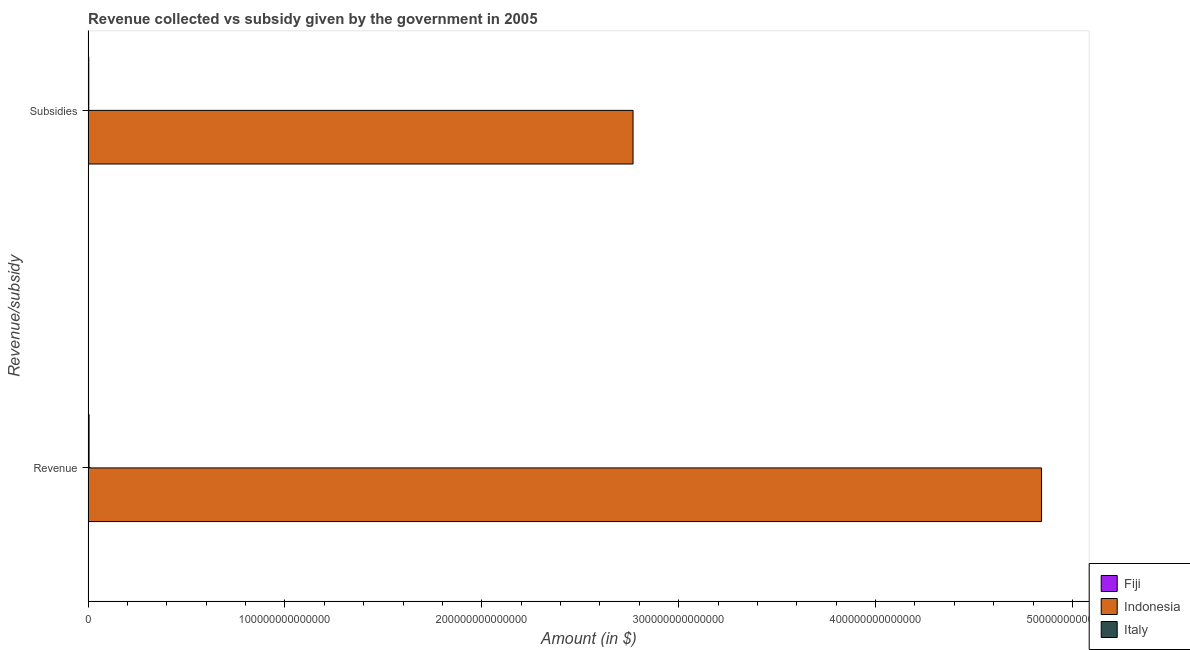How many bars are there on the 1st tick from the top?
Offer a very short reply. 3. How many bars are there on the 2nd tick from the bottom?
Ensure brevity in your answer.  3. What is the label of the 1st group of bars from the top?
Provide a short and direct response. Subsidies. What is the amount of subsidies given in Indonesia?
Give a very brief answer. 2.77e+14. Across all countries, what is the maximum amount of revenue collected?
Your answer should be very brief. 4.84e+14. Across all countries, what is the minimum amount of subsidies given?
Your answer should be very brief. 2.88e+08. In which country was the amount of revenue collected minimum?
Offer a terse response. Fiji. What is the total amount of subsidies given in the graph?
Keep it short and to the point. 2.77e+14. What is the difference between the amount of subsidies given in Fiji and that in Indonesia?
Give a very brief answer. -2.77e+14. What is the difference between the amount of revenue collected in Fiji and the amount of subsidies given in Italy?
Ensure brevity in your answer.  -3.48e+11. What is the average amount of revenue collected per country?
Provide a short and direct response. 1.62e+14. What is the difference between the amount of revenue collected and amount of subsidies given in Indonesia?
Offer a terse response. 2.07e+14. What is the ratio of the amount of subsidies given in Indonesia to that in Fiji?
Your answer should be compact. 9.62e+05. How many countries are there in the graph?
Your answer should be compact. 3. What is the difference between two consecutive major ticks on the X-axis?
Your answer should be very brief. 1.00e+14. Where does the legend appear in the graph?
Provide a short and direct response. Bottom right. How many legend labels are there?
Offer a very short reply. 3. What is the title of the graph?
Offer a very short reply. Revenue collected vs subsidy given by the government in 2005. Does "East Asia (all income levels)" appear as one of the legend labels in the graph?
Make the answer very short. No. What is the label or title of the X-axis?
Keep it short and to the point. Amount (in $). What is the label or title of the Y-axis?
Provide a short and direct response. Revenue/subsidy. What is the Amount (in $) in Fiji in Revenue?
Ensure brevity in your answer.  1.22e+09. What is the Amount (in $) of Indonesia in Revenue?
Keep it short and to the point. 4.84e+14. What is the Amount (in $) in Italy in Revenue?
Your answer should be compact. 5.03e+11. What is the Amount (in $) of Fiji in Subsidies?
Offer a very short reply. 2.88e+08. What is the Amount (in $) in Indonesia in Subsidies?
Your response must be concise. 2.77e+14. What is the Amount (in $) of Italy in Subsidies?
Your answer should be very brief. 3.49e+11. Across all Revenue/subsidy, what is the maximum Amount (in $) of Fiji?
Your answer should be very brief. 1.22e+09. Across all Revenue/subsidy, what is the maximum Amount (in $) in Indonesia?
Ensure brevity in your answer.  4.84e+14. Across all Revenue/subsidy, what is the maximum Amount (in $) of Italy?
Offer a very short reply. 5.03e+11. Across all Revenue/subsidy, what is the minimum Amount (in $) in Fiji?
Provide a succinct answer. 2.88e+08. Across all Revenue/subsidy, what is the minimum Amount (in $) in Indonesia?
Offer a terse response. 2.77e+14. Across all Revenue/subsidy, what is the minimum Amount (in $) in Italy?
Ensure brevity in your answer.  3.49e+11. What is the total Amount (in $) of Fiji in the graph?
Provide a succinct answer. 1.50e+09. What is the total Amount (in $) in Indonesia in the graph?
Provide a short and direct response. 7.61e+14. What is the total Amount (in $) of Italy in the graph?
Ensure brevity in your answer.  8.53e+11. What is the difference between the Amount (in $) of Fiji in Revenue and that in Subsidies?
Keep it short and to the point. 9.28e+08. What is the difference between the Amount (in $) of Indonesia in Revenue and that in Subsidies?
Give a very brief answer. 2.07e+14. What is the difference between the Amount (in $) in Italy in Revenue and that in Subsidies?
Ensure brevity in your answer.  1.54e+11. What is the difference between the Amount (in $) of Fiji in Revenue and the Amount (in $) of Indonesia in Subsidies?
Your response must be concise. -2.77e+14. What is the difference between the Amount (in $) in Fiji in Revenue and the Amount (in $) in Italy in Subsidies?
Your answer should be very brief. -3.48e+11. What is the difference between the Amount (in $) in Indonesia in Revenue and the Amount (in $) in Italy in Subsidies?
Make the answer very short. 4.84e+14. What is the average Amount (in $) of Fiji per Revenue/subsidy?
Give a very brief answer. 7.52e+08. What is the average Amount (in $) in Indonesia per Revenue/subsidy?
Your answer should be compact. 3.81e+14. What is the average Amount (in $) in Italy per Revenue/subsidy?
Offer a very short reply. 4.26e+11. What is the difference between the Amount (in $) of Fiji and Amount (in $) of Indonesia in Revenue?
Ensure brevity in your answer.  -4.84e+14. What is the difference between the Amount (in $) in Fiji and Amount (in $) in Italy in Revenue?
Your response must be concise. -5.02e+11. What is the difference between the Amount (in $) of Indonesia and Amount (in $) of Italy in Revenue?
Make the answer very short. 4.84e+14. What is the difference between the Amount (in $) in Fiji and Amount (in $) in Indonesia in Subsidies?
Keep it short and to the point. -2.77e+14. What is the difference between the Amount (in $) of Fiji and Amount (in $) of Italy in Subsidies?
Ensure brevity in your answer.  -3.49e+11. What is the difference between the Amount (in $) of Indonesia and Amount (in $) of Italy in Subsidies?
Ensure brevity in your answer.  2.76e+14. What is the ratio of the Amount (in $) in Fiji in Revenue to that in Subsidies?
Offer a very short reply. 4.22. What is the ratio of the Amount (in $) of Indonesia in Revenue to that in Subsidies?
Your answer should be compact. 1.75. What is the ratio of the Amount (in $) of Italy in Revenue to that in Subsidies?
Offer a terse response. 1.44. What is the difference between the highest and the second highest Amount (in $) in Fiji?
Ensure brevity in your answer.  9.28e+08. What is the difference between the highest and the second highest Amount (in $) in Indonesia?
Offer a very short reply. 2.07e+14. What is the difference between the highest and the second highest Amount (in $) of Italy?
Provide a succinct answer. 1.54e+11. What is the difference between the highest and the lowest Amount (in $) of Fiji?
Give a very brief answer. 9.28e+08. What is the difference between the highest and the lowest Amount (in $) of Indonesia?
Give a very brief answer. 2.07e+14. What is the difference between the highest and the lowest Amount (in $) of Italy?
Keep it short and to the point. 1.54e+11. 